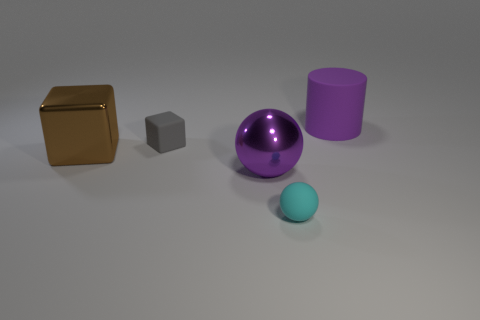What number of balls are behind the large brown metal cube? There are no balls located behind the large brown metal cube in the image provided. 